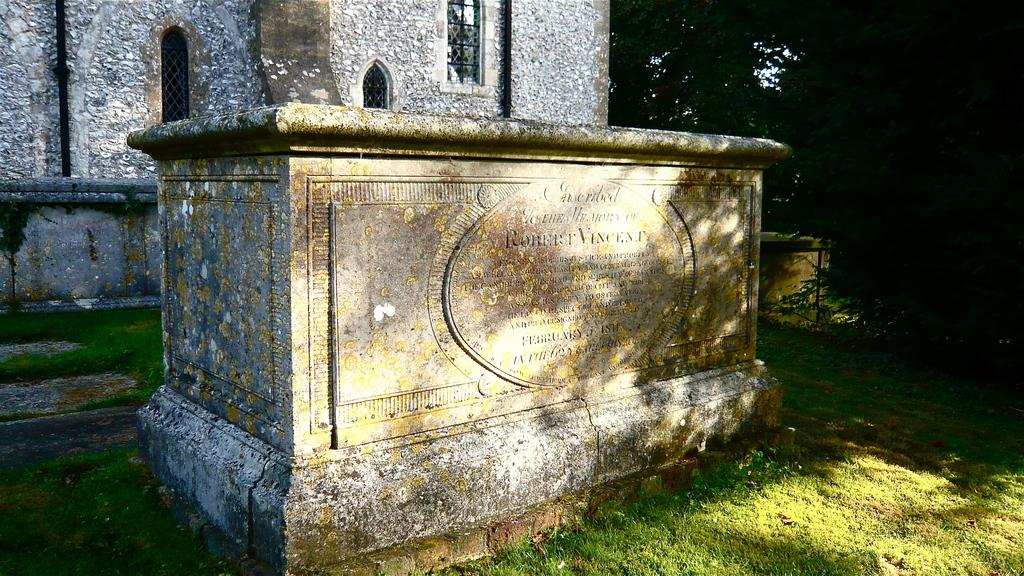What is the main object in the image? There is a headstone in the image. What type of structure is visible in the background? There is a wall with windows in the image. What type of vegetation can be seen in the image? There are trees in the image. What is the purpose of the jar in the image? There is no jar present in the image. 